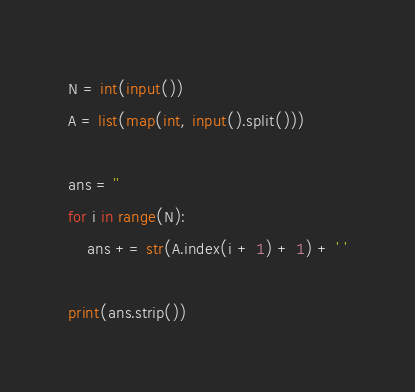<code> <loc_0><loc_0><loc_500><loc_500><_Python_>N = int(input())
A = list(map(int, input().split()))

ans = ''
for i in range(N):
    ans += str(A.index(i + 1) + 1) + ' '

print(ans.strip())
</code> 